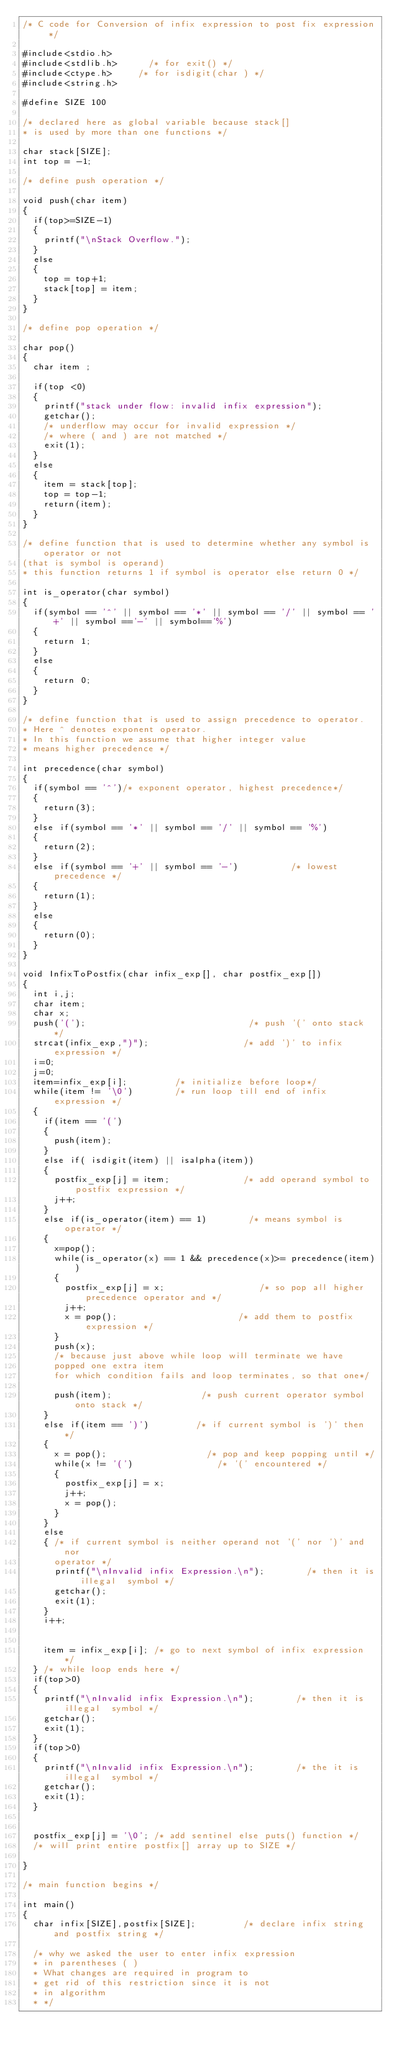<code> <loc_0><loc_0><loc_500><loc_500><_C_>/* C code for Conversion of infix expression to post fix expression */

#include<stdio.h>
#include<stdlib.h>      /* for exit() */
#include<ctype.h>     /* for isdigit(char ) */
#include<string.h>

#define SIZE 100

/* declared here as global variable because stack[]
* is used by more than one functions */

char stack[SIZE];
int top = -1;

/* define push operation */

void push(char item)
{
	if(top>=SIZE-1)
	{
		printf("\nStack Overflow.");
	}
	else
	{
		top = top+1;
		stack[top] = item;
	}
}

/* define pop operation */

char pop()
{
	char item ;

	if(top <0)
	{
		printf("stack under flow: invalid infix expression");
		getchar();
		/* underflow may occur for invalid expression */
		/* where ( and ) are not matched */
		exit(1);
	}
	else
	{
		item = stack[top];
		top = top-1;
		return(item);
	}
}

/* define function that is used to determine whether any symbol is operator or not
(that is symbol is operand)
* this function returns 1 if symbol is operator else return 0 */

int is_operator(char symbol)
{
	if(symbol == '^' || symbol == '*' || symbol == '/' || symbol == '+' || symbol =='-' || symbol=='%')
	{
		return 1;
	}
	else
	{
		return 0;
	}
}

/* define function that is used to assign precedence to operator.
* Here ^ denotes exponent operator.
* In this function we assume that higher integer value
* means higher precedence */

int precedence(char symbol)
{
	if(symbol == '^')/* exponent operator, highest precedence*/
	{
		return(3);
	}
	else if(symbol == '*' || symbol == '/' || symbol == '%')
	{
		return(2);
	}
	else if(symbol == '+' || symbol == '-')          /* lowest precedence */
	{
		return(1);
	}
	else
	{
		return(0);
	}
}

void InfixToPostfix(char infix_exp[], char postfix_exp[])
{
	int i,j;
	char item;
	char x;
	push('(');                               /* push '(' onto stack */
	strcat(infix_exp,")");                  /* add ')' to infix expression */
	i=0;
	j=0;
	item=infix_exp[i];         /* initialize before loop*/
	while(item != '\0')        /* run loop till end of infix expression */
	{
		if(item == '(')
		{
			push(item);
		}
		else if( isdigit(item) || isalpha(item))
		{
			postfix_exp[j] = item;              /* add operand symbol to postfix expression */
			j++;
		}
		else if(is_operator(item) == 1)        /* means symbol is operator */
		{
			x=pop();
			while(is_operator(x) == 1 && precedence(x)>= precedence(item))
			{
				postfix_exp[j] = x;                  /* so pop all higher precedence operator and */
				j++;
				x = pop();                       /* add them to postfix expression */
			}
			push(x);
			/* because just above while loop will terminate we have
			popped one extra item
			for which condition fails and loop terminates, so that one*/

			push(item);                 /* push current operator symbol onto stack */
		}
		else if(item == ')')         /* if current symbol is ')' then */
		{
			x = pop();                   /* pop and keep popping until */
			while(x != '(')                /* '(' encountered */
			{
				postfix_exp[j] = x;
				j++;
				x = pop();
			}
		}
		else
		{ /* if current symbol is neither operand not '(' nor ')' and nor
			operator */
			printf("\nInvalid infix Expression.\n");        /* then it is illegal  symbol */
			getchar();
			exit(1);
		}
		i++;


		item = infix_exp[i]; /* go to next symbol of infix expression */
	} /* while loop ends here */
	if(top>0)
	{
		printf("\nInvalid infix Expression.\n");        /* then it is illegal  symbol */
		getchar();
		exit(1);
	}
	if(top>0)
	{
		printf("\nInvalid infix Expression.\n");        /* the it is illegal  symbol */
		getchar();
		exit(1);
	}


	postfix_exp[j] = '\0'; /* add sentinel else puts() function */
	/* will print entire postfix[] array up to SIZE */

}

/* main function begins */

int main()
{
	char infix[SIZE],postfix[SIZE];         /* declare infix string and postfix string */

	/* why we asked the user to enter infix expression
	* in parentheses ( )
	* What changes are required in program to
	* get rid of this restriction since it is not
	* in algorithm
	* */</code> 